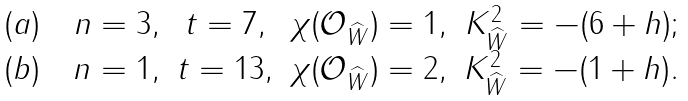Convert formula to latex. <formula><loc_0><loc_0><loc_500><loc_500>\begin{array} { c c c c } ( a ) \quad n = 3 , & t = 7 , & \chi ( \mathcal { O } _ { \widehat { W } } ) = 1 , & K _ { \widehat { W } } ^ { 2 } = - ( 6 + h ) ; \\ ( b ) \quad n = 1 , & t = 1 3 , & \chi ( \mathcal { O } _ { \widehat { W } } ) = 2 , & K _ { \widehat { W } } ^ { 2 } = - ( 1 + h ) . \\ \end{array}</formula> 